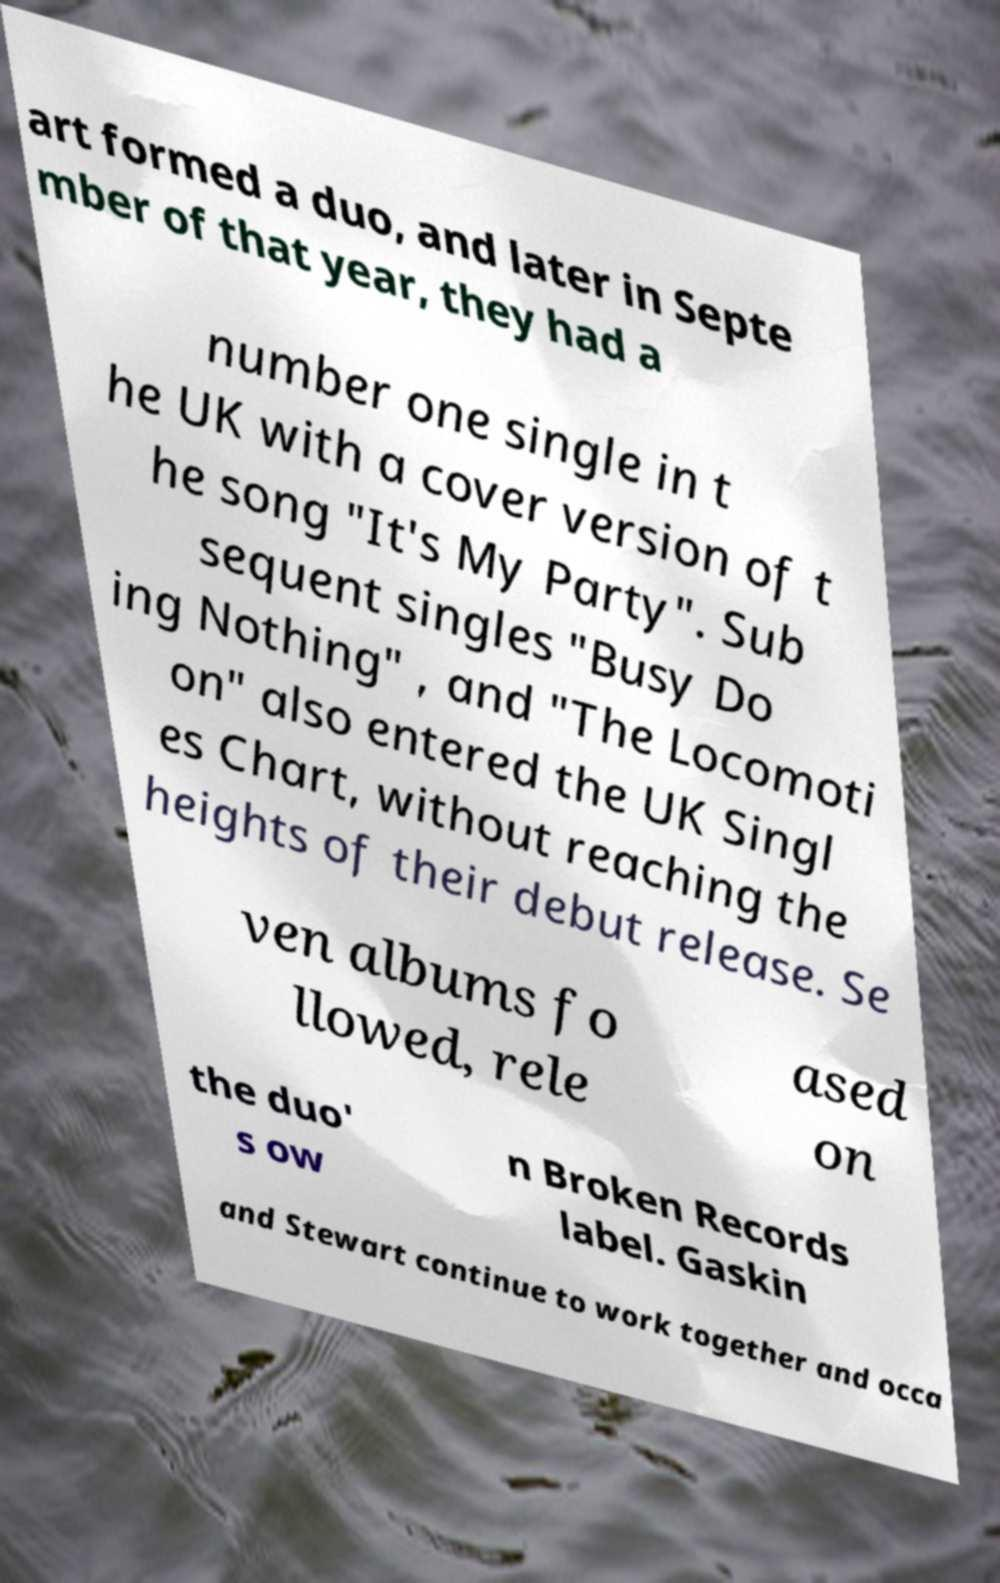For documentation purposes, I need the text within this image transcribed. Could you provide that? art formed a duo, and later in Septe mber of that year, they had a number one single in t he UK with a cover version of t he song "It's My Party". Sub sequent singles "Busy Do ing Nothing" , and "The Locomoti on" also entered the UK Singl es Chart, without reaching the heights of their debut release. Se ven albums fo llowed, rele ased on the duo' s ow n Broken Records label. Gaskin and Stewart continue to work together and occa 